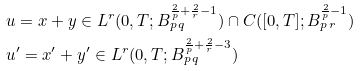<formula> <loc_0><loc_0><loc_500><loc_500>& u = x + y \in L ^ { r } ( 0 , T ; B ^ { \frac { 2 } { p } + \frac { 2 } { r } - 1 } _ { p \, q } ) \cap C ( [ 0 , T ] ; B ^ { \frac { 2 } { p } - 1 } _ { p \, r } ) \\ & u ^ { \prime } = x ^ { \prime } + y ^ { \prime } \in L ^ { r } ( 0 , T ; B ^ { \frac { 2 } { p } + \frac { 2 } { r } - 3 } _ { p \, q } ) \\</formula> 